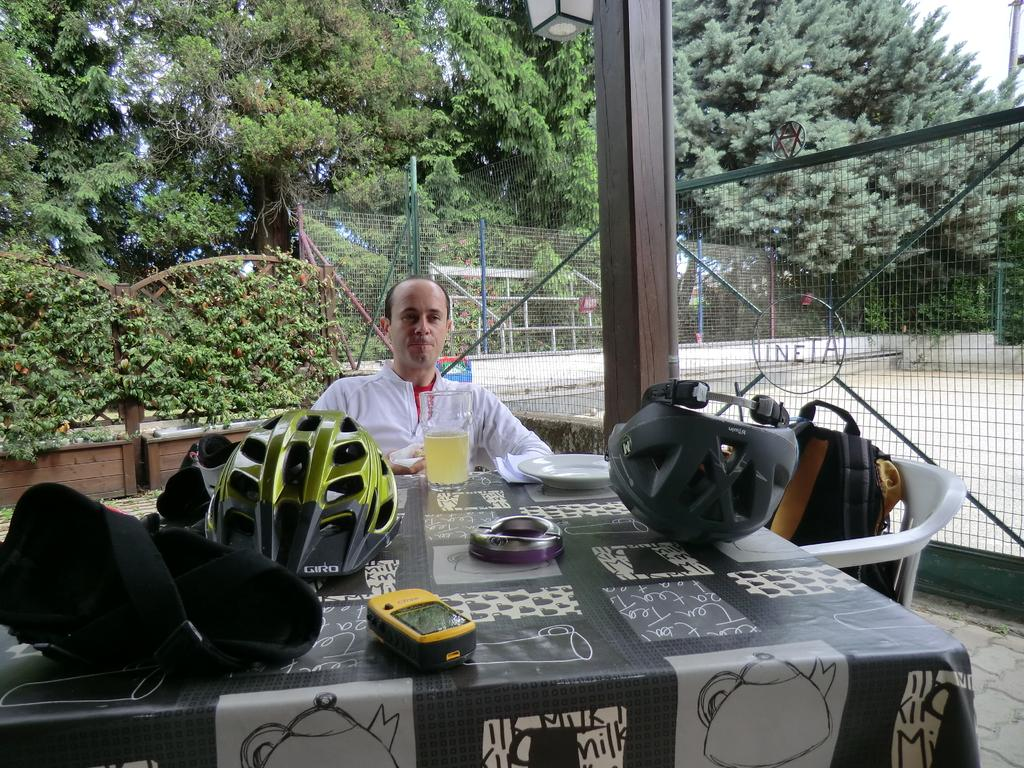What objects are present in large quantities in the image? There are many helmets in the image. What else can be seen on the table besides helmets? There are other things kept on the table in the image. What is the person in the image doing? A person is sitting on a chair in the image. What type of natural environment is visible in the image? Trees are visible in the image. What type of barrier can be seen in the image? There is fencing in the image. How many quilts are visible in the image? There are no quilts visible in the image. How many feet are visible in the image? There is no mention of feet in the provided facts, so we cannot determine how many are visible in the image. 